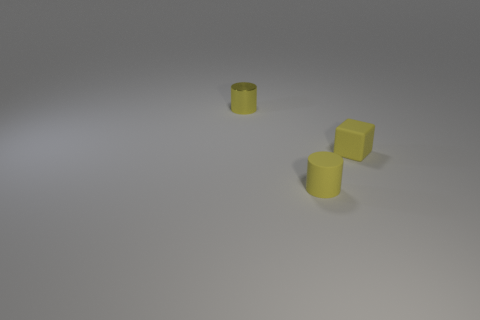Do the tiny yellow rubber thing that is in front of the block and the yellow matte thing that is on the right side of the rubber cylinder have the same shape?
Provide a short and direct response. No. How many things are either tiny cylinders or tiny yellow matte cylinders that are to the right of the metal cylinder?
Ensure brevity in your answer.  2. There is a tiny metal object that is the same color as the tiny cube; what is its shape?
Provide a short and direct response. Cylinder. What number of brown metallic cylinders are the same size as the yellow matte cube?
Ensure brevity in your answer.  0. What number of blue things are either small blocks or small cylinders?
Offer a very short reply. 0. What is the shape of the yellow thing that is right of the yellow cylinder right of the tiny shiny cylinder?
Ensure brevity in your answer.  Cube. The yellow shiny thing that is the same size as the rubber cube is what shape?
Offer a terse response. Cylinder. Is there a tiny rubber object of the same color as the matte block?
Provide a short and direct response. Yes. Are there the same number of yellow things that are in front of the yellow shiny object and objects behind the yellow matte cube?
Provide a short and direct response. No. There is a metal object; does it have the same shape as the matte object behind the yellow rubber cylinder?
Offer a very short reply. No. 